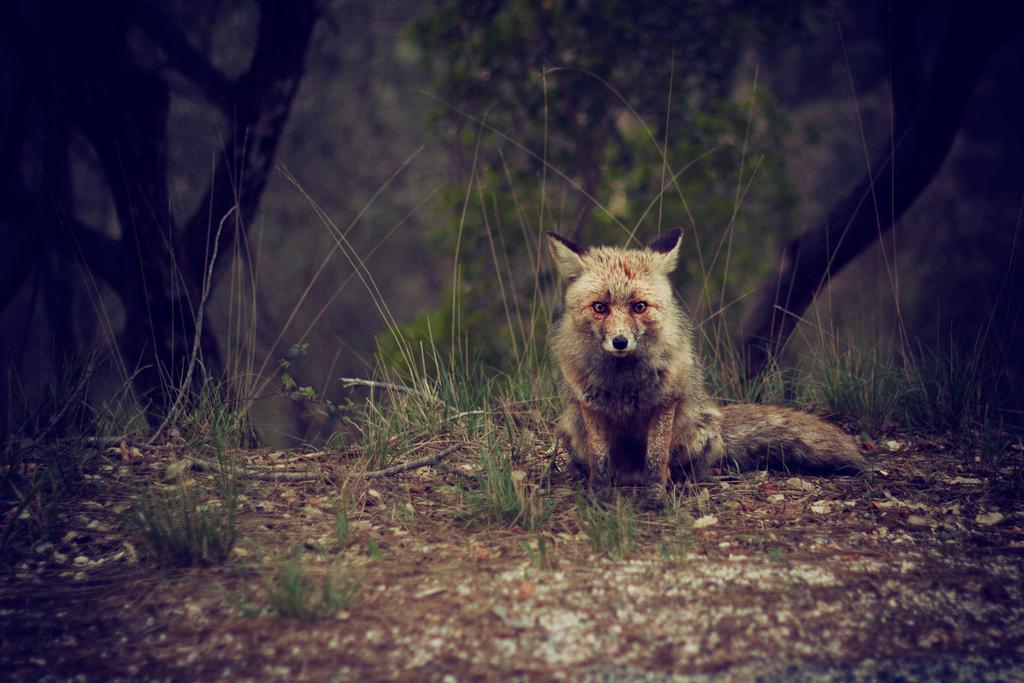Can you describe this image briefly? In the foreground I can see a fox on the ground and grass. In the background I can see trees. This image is taken may be in the forest during night. 